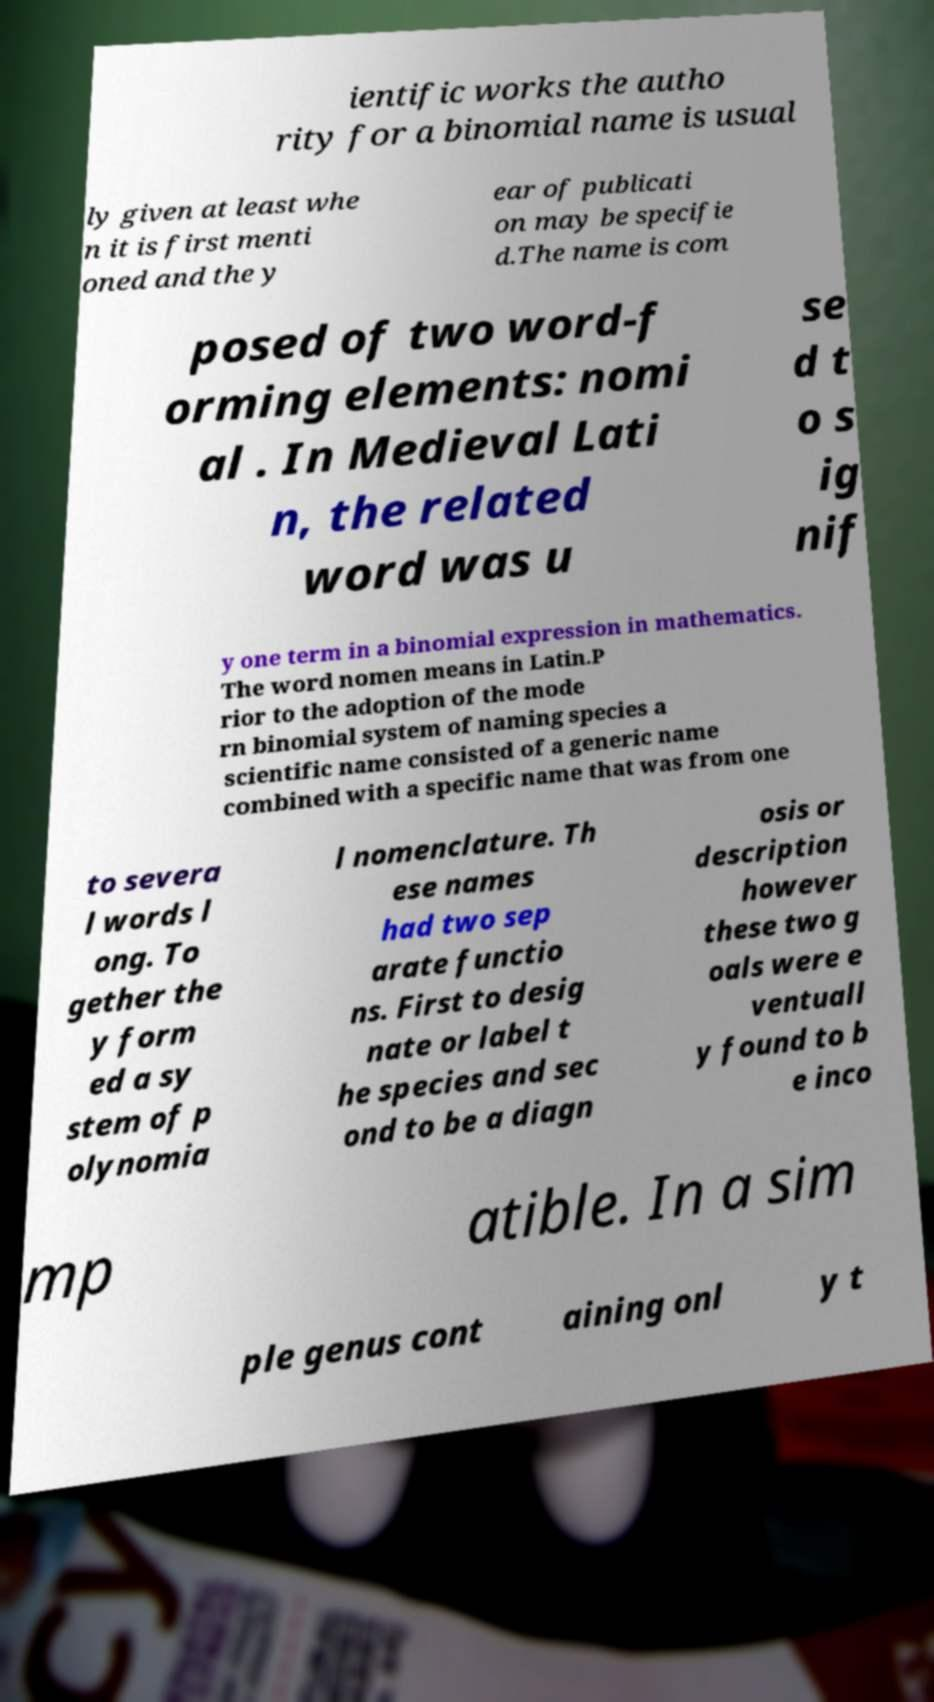Can you read and provide the text displayed in the image?This photo seems to have some interesting text. Can you extract and type it out for me? ientific works the autho rity for a binomial name is usual ly given at least whe n it is first menti oned and the y ear of publicati on may be specifie d.The name is com posed of two word-f orming elements: nomi al . In Medieval Lati n, the related word was u se d t o s ig nif y one term in a binomial expression in mathematics. The word nomen means in Latin.P rior to the adoption of the mode rn binomial system of naming species a scientific name consisted of a generic name combined with a specific name that was from one to severa l words l ong. To gether the y form ed a sy stem of p olynomia l nomenclature. Th ese names had two sep arate functio ns. First to desig nate or label t he species and sec ond to be a diagn osis or description however these two g oals were e ventuall y found to b e inco mp atible. In a sim ple genus cont aining onl y t 